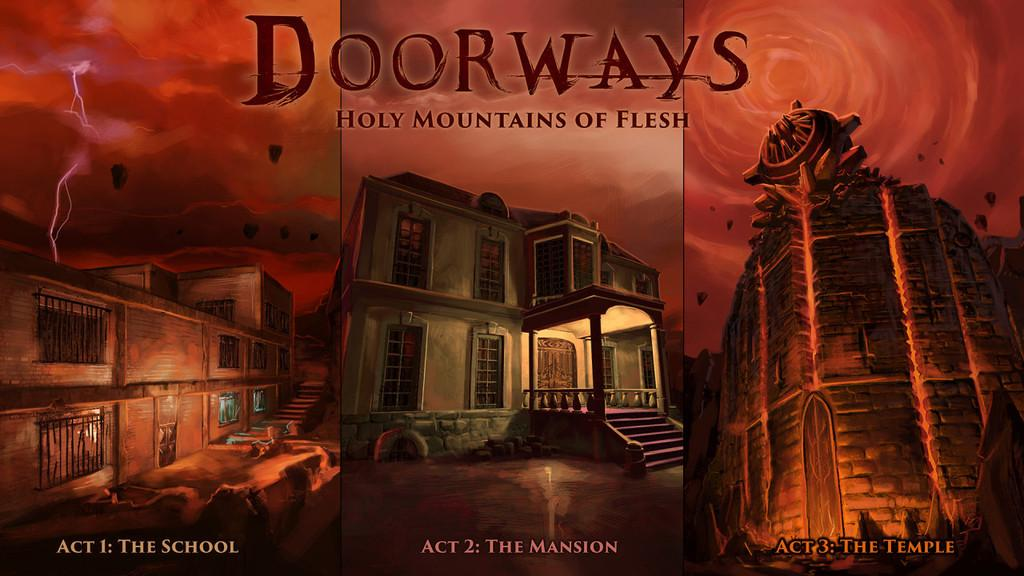<image>
Write a terse but informative summary of the picture. Doorways Holy Mountains of Flesh is shown to have three acts. 